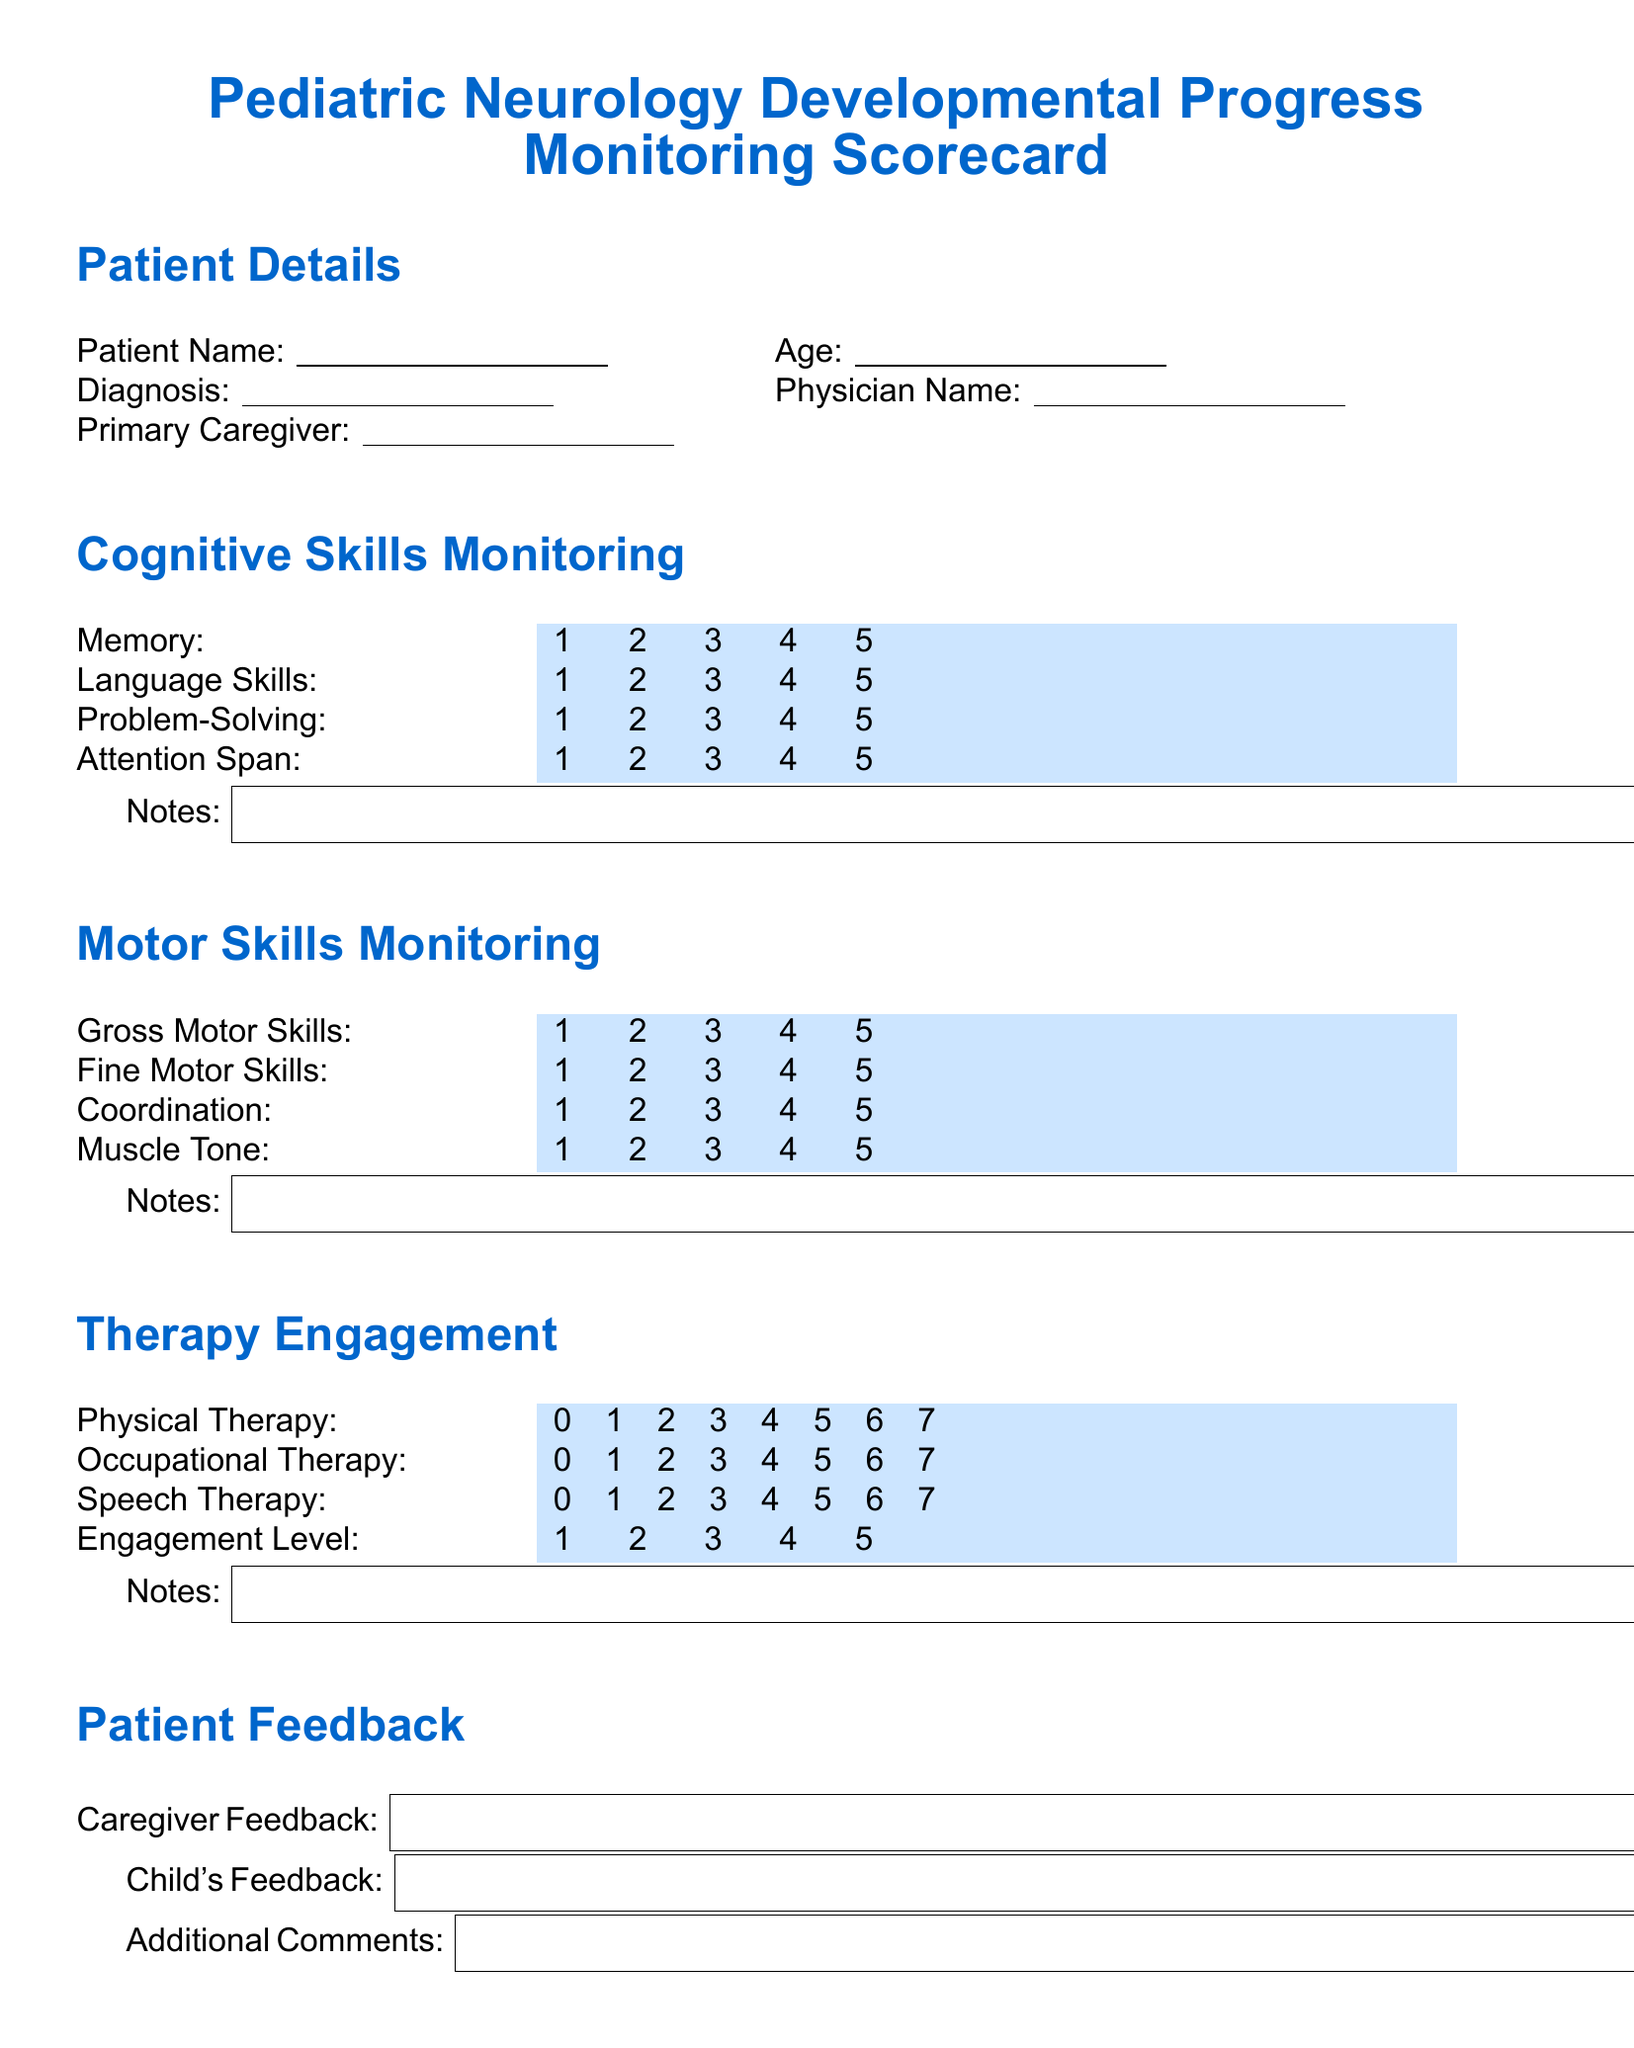What is the age of the patient? The patient's age is indicated in the patient details section and is left blank for the caregiver to fill in.
Answer: Blank Who is the primary caregiver? The primary caregiver's name is indicated in the patient details section and is left blank for the caregiver to fill in.
Answer: Blank What is the highest score for Memory in cognitive skills monitoring? The highest score for Memory on the scale provided is 5 as indicated in the cognitive skills monitoring table.
Answer: 5 What is the engagement level score in therapy engagement? The engagement level score is found in the therapy engagement section, which allows a maximum score of 5.
Answer: 5 How many therapy types are listed in the therapy engagement section? The number of therapy types is found by counting the sections listed under therapy engagement, which includes three different types.
Answer: 3 Which skill has the lowest score range in the motor skills monitoring? The motor skills monitoring section features multiple skills, each with a rating from 1 to 5, and the lowest is 1.
Answer: 1 What type of feedback is collected from caregivers? The type of feedback is categorized as Caregiver Feedback, as indicated in the patient feedback section.
Answer: Caregiver Feedback What are the four cognitive skills monitored in this scorecard? The cognitive skills monitored include Memory, Language Skills, Problem-Solving, and Attention Span as seen in the cognitive skills monitoring section.
Answer: Memory, Language Skills, Problem-Solving, Attention Span What is the color used for highlighting scores in this scorecard? The color used for highlighting scores in the document is light teal, used in various sections for consistency.
Answer: Light teal 